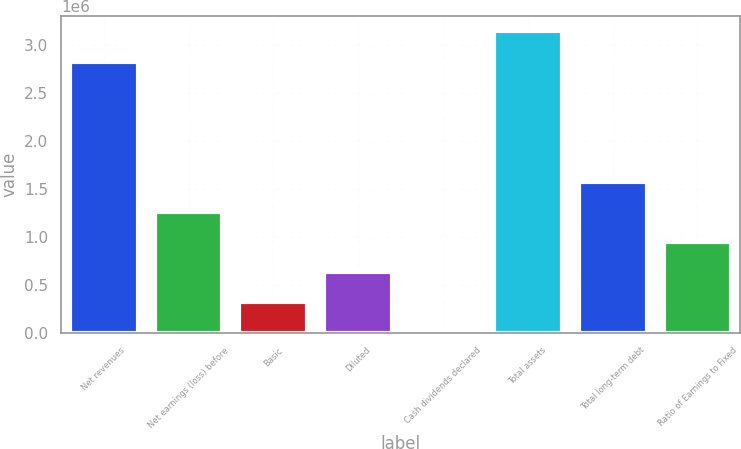<chart> <loc_0><loc_0><loc_500><loc_500><bar_chart><fcel>Net revenues<fcel>Net earnings (loss) before<fcel>Basic<fcel>Diluted<fcel>Cash dividends declared<fcel>Total assets<fcel>Total long-term debt<fcel>Ratio of Earnings to Fixed<nl><fcel>2.81623e+06<fcel>1.25715e+06<fcel>314288<fcel>628576<fcel>0.12<fcel>3.14288e+06<fcel>1.57144e+06<fcel>942864<nl></chart> 